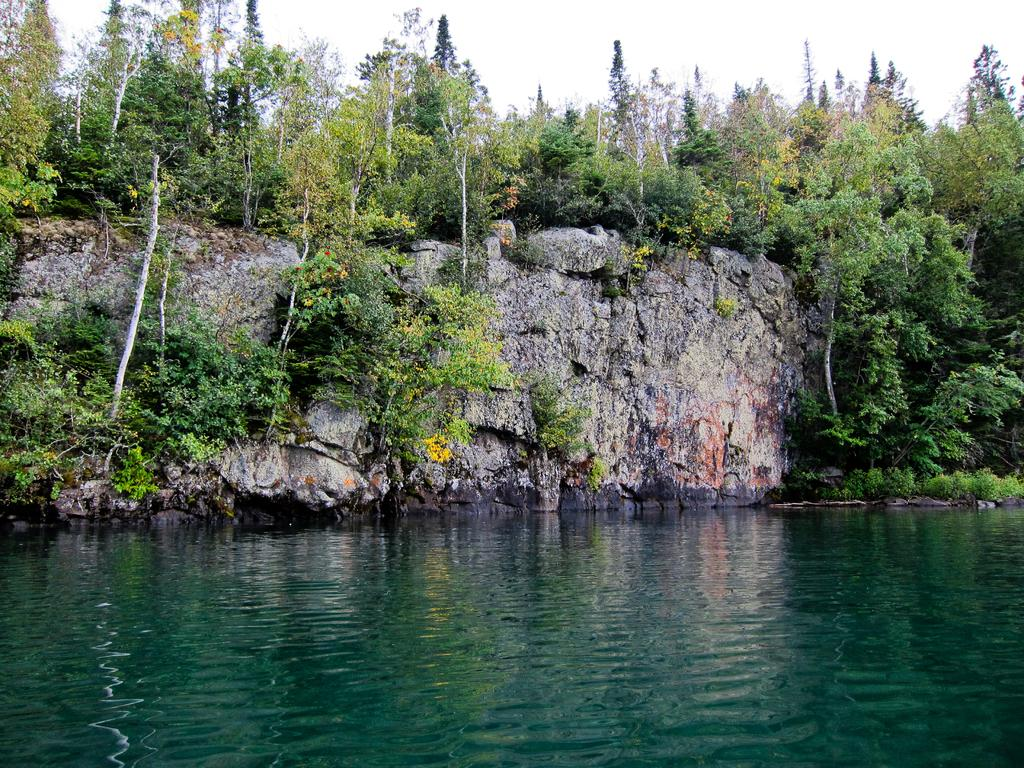What is the main subject of the image? The main subject of the image is a rock. What other natural elements can be seen in the image? There are plants, trees, and water visible in the image. What part of the natural environment is visible at the top of the image? The sky is visible at the top of the image. What type of frame is used to display the request in the image? There is no frame or request present in the image; it features a rock, plants, trees, water, and the sky. 